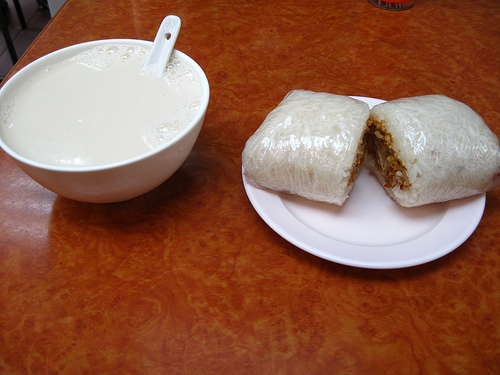<image>
Can you confirm if the cake is on the plate? Yes. Looking at the image, I can see the cake is positioned on top of the plate, with the plate providing support. 